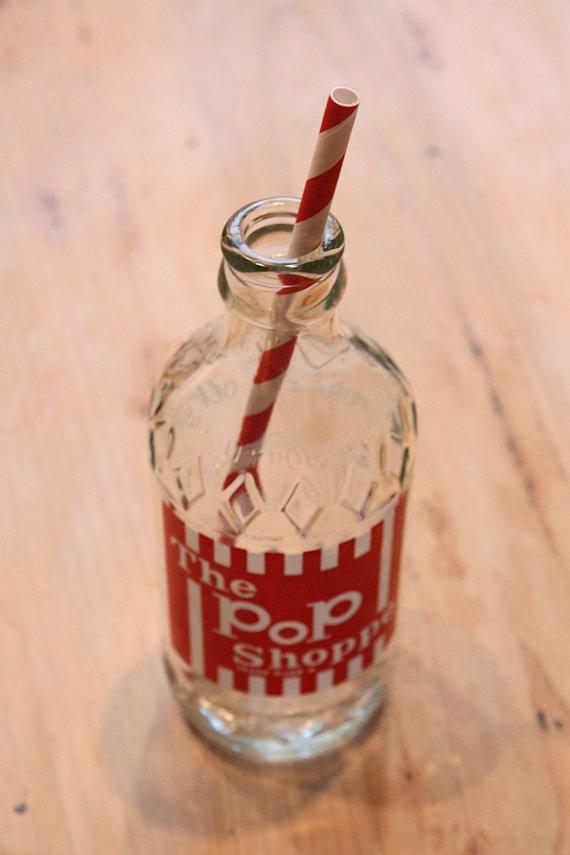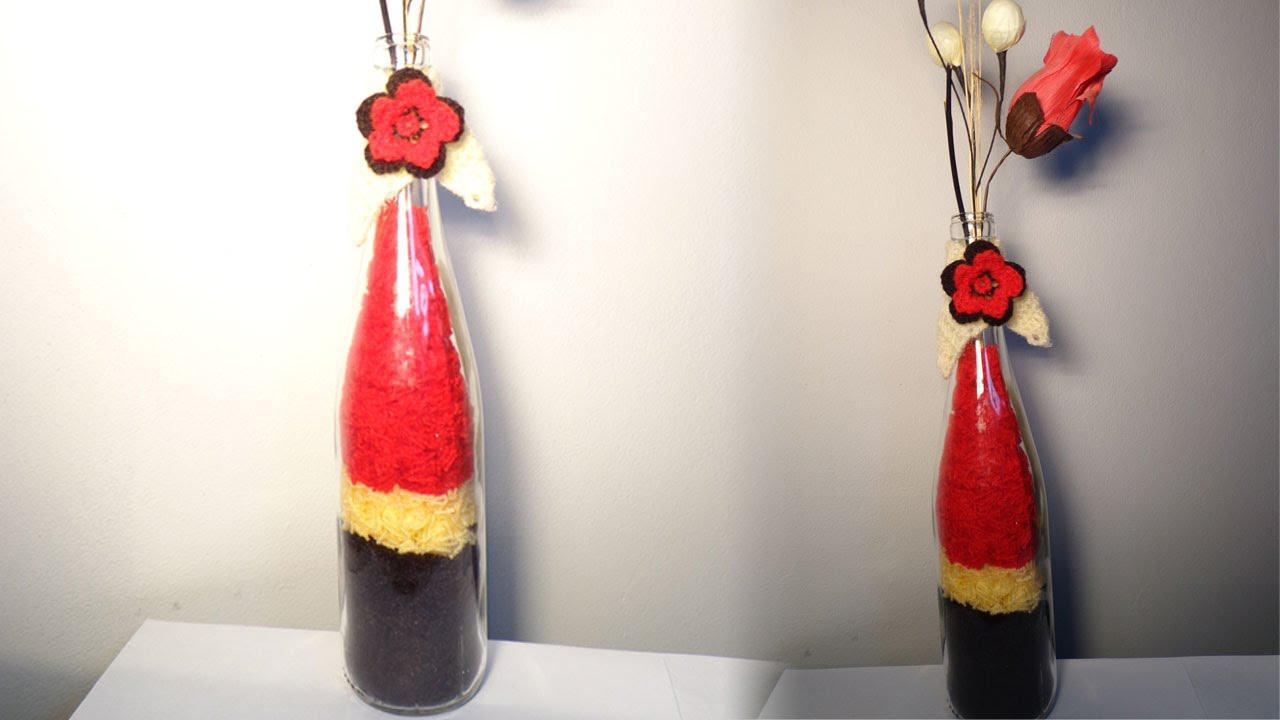The first image is the image on the left, the second image is the image on the right. For the images displayed, is the sentence "the left and right image contains the same number of glass bottles." factually correct? Answer yes or no. No. The first image is the image on the left, the second image is the image on the right. For the images displayed, is the sentence "there are two glass containers in the image pair" factually correct? Answer yes or no. No. 